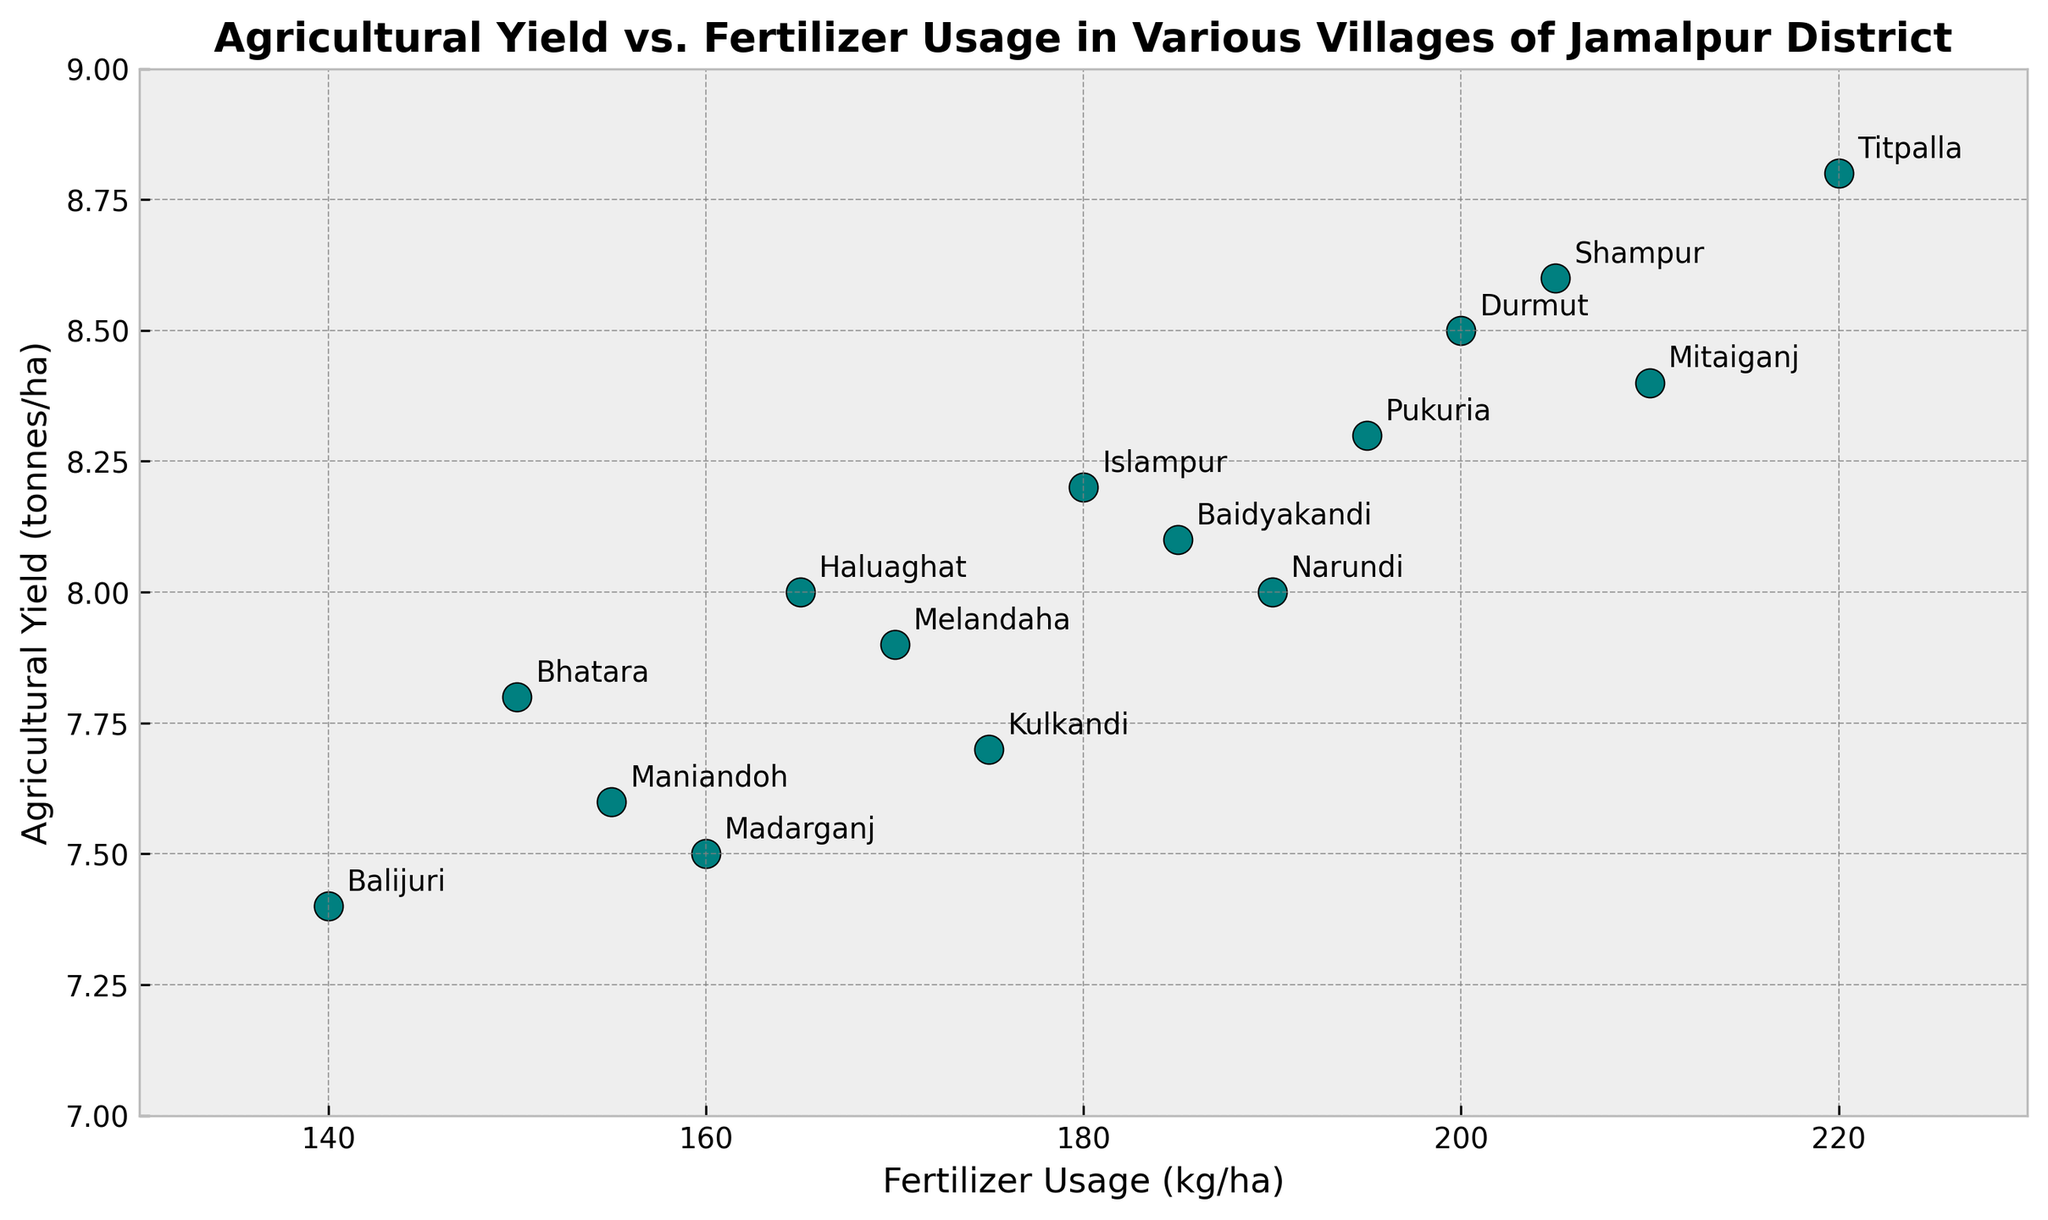What's the range of fertilizer usage among all villages? To find the range, subtract the minimum fertilizer usage value from the maximum fertilizer usage value. The maximum value is 220 kg/ha (Titpalla) and the minimum value is 140 kg/ha (Balijuri). So, the range is 220 - 140.
Answer: 80 kg/ha Which village has the highest agricultural yield and what is its fertilizer usage? Identify the point with the highest yield on the y-axis, which is Titpalla with a yield of 8.8 tonnes/ha. The corresponding fertilizer usage for Titpalla is 220 kg/ha as seen on the x-axis.
Answer: Titpalla, 220 kg/ha Is there a trend between fertilizer usage and agricultural yield? Observing the scatter plot, as the fertilizer usage (x-axis) increases, the agricultural yield (y-axis) also tends to increase for most points, indicating a positive correlation or trend.
Answer: Positive correlation Compare the agricultural yields of Durmut and Melandaha. Which village has a higher yield? Locate the points for Durmut and Melandaha on the scatter plot. Durmut has a yield of 8.5 tonnes/ha, and Melandaha has a yield of 7.9 tonnes/ha. Comparatively, Durmut has a higher yield.
Answer: Durmut What is the average agricultural yield across all villages? To find the average yield, sum all the yield values and divide by the number of villages. Summing the yields (7.8 + 8.5 + 8.2 + 7.5 + 7.9 + 8.4 + 8 + 8.8 + 7.4 + 8.1 + 8.3 + 7.7 + 7.6 + 8 + 8.6) equals 122.8. Dividing by 15 (the number of villages) gives 8.19 tonnes/ha.
Answer: 8.19 tonnes/ha How much more fertilizer is used in Pukuria compared to Kulkandi? Pukuria's fertilizer usage is 195 kg/ha, and Kulkandi's usage is 175 kg/ha. Subtracting Kulkandi's usage from Pukuria's gives 195 - 175.
Answer: 20 kg/ha Which village has the lowest yield and what is its corresponding fertilizer usage? Identify the point with the lowest yield on the y-axis, which is Balijuri with a yield of 7.4 tonnes/ha. The corresponding fertilizer usage is 140 kg/ha.
Answer: Balijuri, 140 kg/ha Between Islampur and Maniandoh, which village uses more fertilizer and by how much? Islampur's fertilizer usage is 180 kg/ha, and Maniandoh's is 155 kg/ha. Subtracting Maniandoh's usage from Islampur's gives 180 - 155.
Answer: Islampur, 25 kg/ha What is the median fertilizer usage among all villages? To find the median, list all fertilizer usage values in ascending order (140, 150, 155, 160, 165, 170, 175, 180, 185, 190, 195, 200, 205, 210, 220) and select the middle value. With 15 values, the middle (8th value) is 180 kg/ha.
Answer: 180 kg/ha 